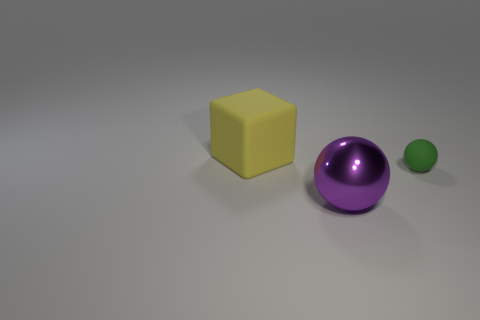Are there any other things that are the same size as the green matte object?
Make the answer very short. No. Are there fewer matte spheres in front of the green matte object than tiny green spheres that are in front of the yellow block?
Give a very brief answer. Yes. Are there any other things that have the same shape as the big matte thing?
Your response must be concise. No. There is a sphere that is in front of the ball right of the purple metal thing; what number of large yellow objects are on the right side of it?
Provide a short and direct response. 0. There is a small matte thing; what number of tiny green matte objects are to the right of it?
Your response must be concise. 0. What number of small green things have the same material as the large yellow block?
Offer a terse response. 1. There is a tiny thing that is the same material as the cube; what is its color?
Keep it short and to the point. Green. What material is the object that is behind the small rubber thing that is on the right side of the big thing that is in front of the tiny green rubber object made of?
Your answer should be very brief. Rubber. Does the ball that is on the left side of the green rubber sphere have the same size as the rubber block?
Make the answer very short. Yes. What number of big objects are rubber things or metallic objects?
Offer a terse response. 2. 